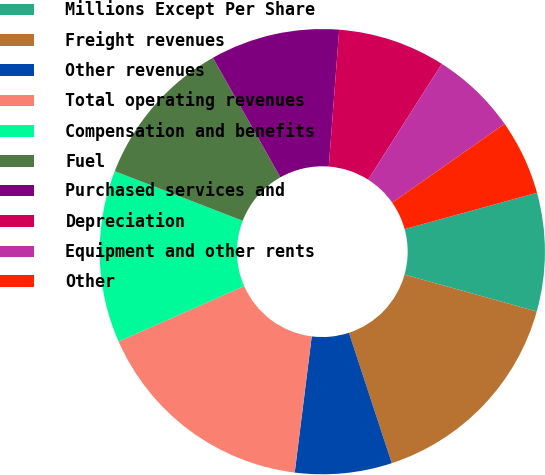<chart> <loc_0><loc_0><loc_500><loc_500><pie_chart><fcel>Millions Except Per Share<fcel>Freight revenues<fcel>Other revenues<fcel>Total operating revenues<fcel>Compensation and benefits<fcel>Fuel<fcel>Purchased services and<fcel>Depreciation<fcel>Equipment and other rents<fcel>Other<nl><fcel>8.59%<fcel>15.62%<fcel>7.03%<fcel>16.41%<fcel>12.5%<fcel>10.94%<fcel>9.38%<fcel>7.81%<fcel>6.25%<fcel>5.47%<nl></chart> 